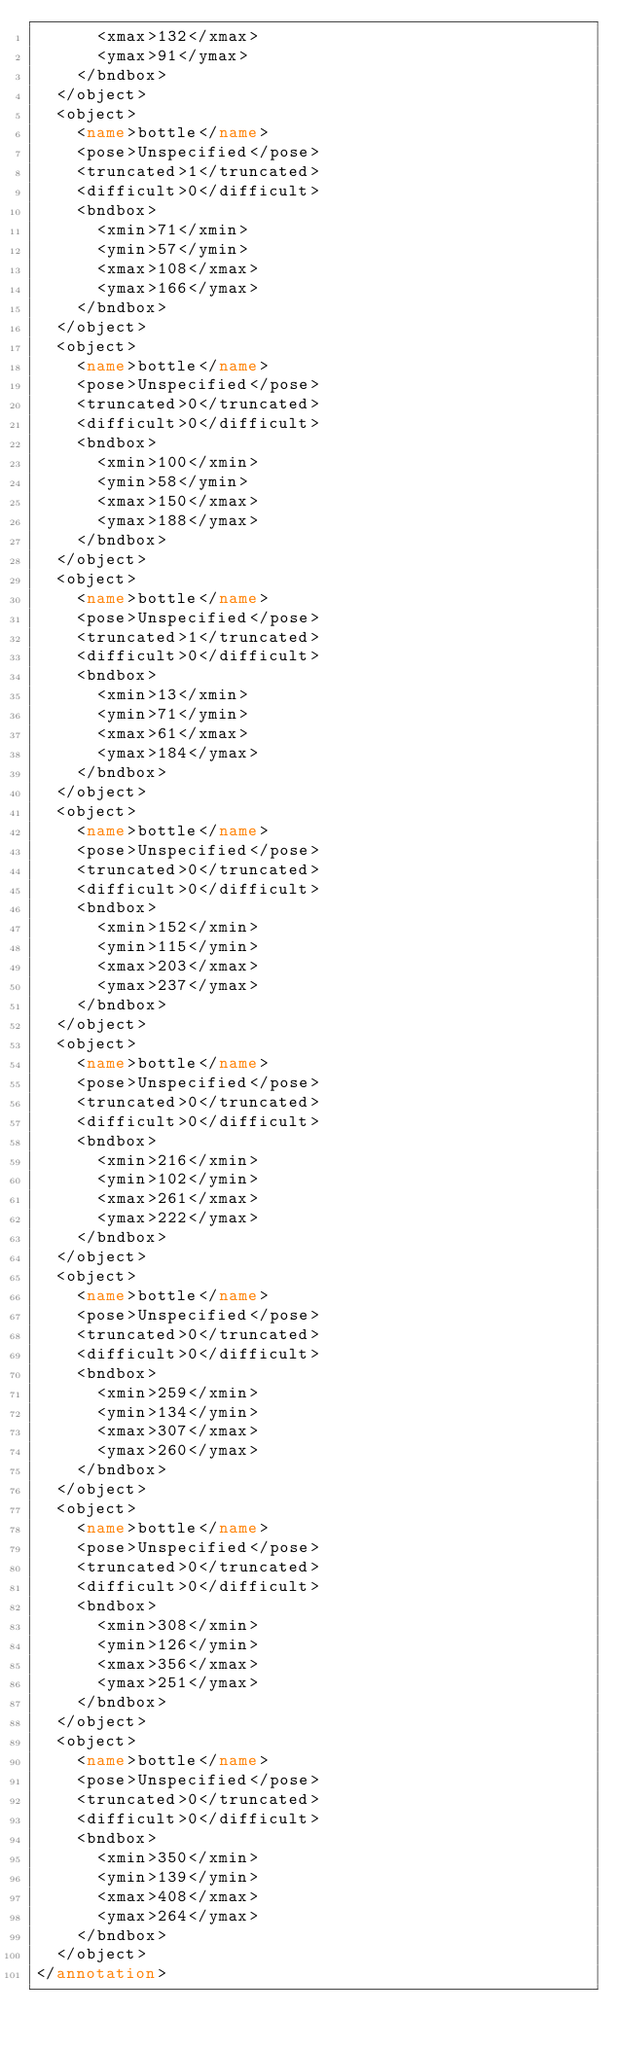Convert code to text. <code><loc_0><loc_0><loc_500><loc_500><_XML_>			<xmax>132</xmax>
			<ymax>91</ymax>
		</bndbox>
	</object>
	<object>
		<name>bottle</name>
		<pose>Unspecified</pose>
		<truncated>1</truncated>
		<difficult>0</difficult>
		<bndbox>
			<xmin>71</xmin>
			<ymin>57</ymin>
			<xmax>108</xmax>
			<ymax>166</ymax>
		</bndbox>
	</object>
	<object>
		<name>bottle</name>
		<pose>Unspecified</pose>
		<truncated>0</truncated>
		<difficult>0</difficult>
		<bndbox>
			<xmin>100</xmin>
			<ymin>58</ymin>
			<xmax>150</xmax>
			<ymax>188</ymax>
		</bndbox>
	</object>
	<object>
		<name>bottle</name>
		<pose>Unspecified</pose>
		<truncated>1</truncated>
		<difficult>0</difficult>
		<bndbox>
			<xmin>13</xmin>
			<ymin>71</ymin>
			<xmax>61</xmax>
			<ymax>184</ymax>
		</bndbox>
	</object>
	<object>
		<name>bottle</name>
		<pose>Unspecified</pose>
		<truncated>0</truncated>
		<difficult>0</difficult>
		<bndbox>
			<xmin>152</xmin>
			<ymin>115</ymin>
			<xmax>203</xmax>
			<ymax>237</ymax>
		</bndbox>
	</object>
	<object>
		<name>bottle</name>
		<pose>Unspecified</pose>
		<truncated>0</truncated>
		<difficult>0</difficult>
		<bndbox>
			<xmin>216</xmin>
			<ymin>102</ymin>
			<xmax>261</xmax>
			<ymax>222</ymax>
		</bndbox>
	</object>
	<object>
		<name>bottle</name>
		<pose>Unspecified</pose>
		<truncated>0</truncated>
		<difficult>0</difficult>
		<bndbox>
			<xmin>259</xmin>
			<ymin>134</ymin>
			<xmax>307</xmax>
			<ymax>260</ymax>
		</bndbox>
	</object>
	<object>
		<name>bottle</name>
		<pose>Unspecified</pose>
		<truncated>0</truncated>
		<difficult>0</difficult>
		<bndbox>
			<xmin>308</xmin>
			<ymin>126</ymin>
			<xmax>356</xmax>
			<ymax>251</ymax>
		</bndbox>
	</object>
	<object>
		<name>bottle</name>
		<pose>Unspecified</pose>
		<truncated>0</truncated>
		<difficult>0</difficult>
		<bndbox>
			<xmin>350</xmin>
			<ymin>139</ymin>
			<xmax>408</xmax>
			<ymax>264</ymax>
		</bndbox>
	</object>
</annotation>
</code> 